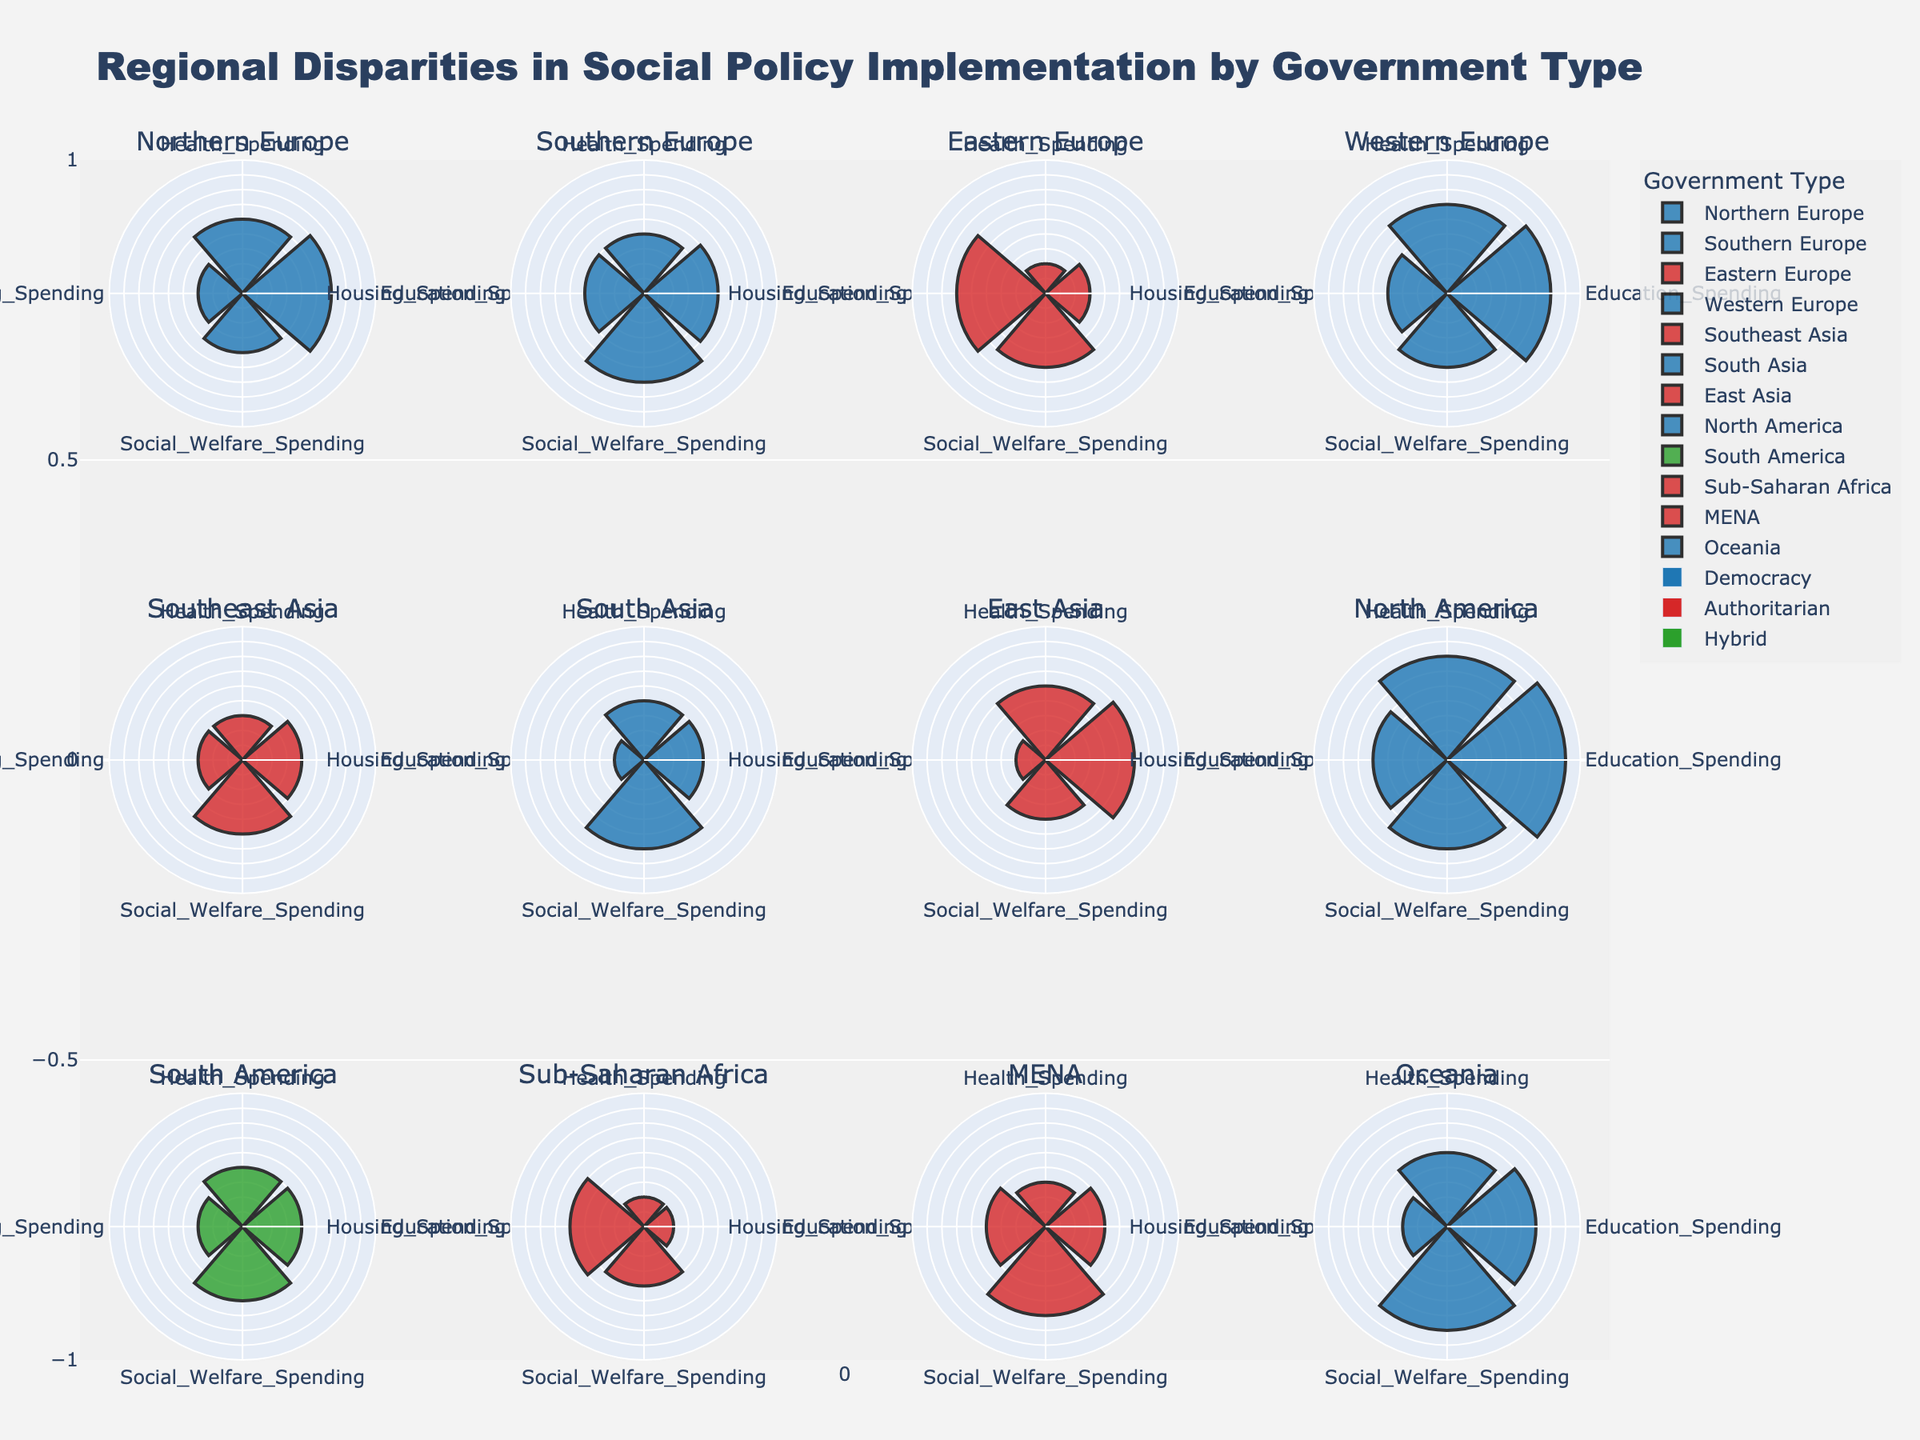Which region spends the most on health? The Northern Europe region, represented by a blue color indicating a democracy, shows the longest bar for health spending.
Answer: Northern Europe What is the government type of Southeast Asia, and how can you tell? The color of the bar polar for Southeast Asia is red, which is mapped to an authoritarian government type.
Answer: Authoritarian Which region under a democracy has the highest education spending? Looking at the rose charts for democratic regions, North America has the longest bar for education spending compared to other regions like Northern Europe, Western Europe, South Asia, and Oceania.
Answer: North America Compare the housing spending between East Asia and Southern Europe. In East Asia (authoritarian, red), the housing spending bar is shorter than in Southern Europe (democracy, blue), indicating lower housing expenditure in East Asia.
Answer: Southern Europe spends more on housing How does social welfare spending in South America compare to MENA? The green bar for South America’s social welfare spending is slightly shorter than the red bar for MENA’s social welfare spending, indicating MENA has marginally higher spending in this category.
Answer: MENA has higher social welfare spending For Authoritarian regions, identify the one with the highest health spending and provide the value. Among the red-colored sections, East Asia has the longest health spending bar, which is marked at 25 units.
Answer: East Asia with 25 units What is the social welfare spending for North America? In the North America subplot (democracy, blue), the bar for social welfare spending reaches up to 30 units.
Answer: 30 units Which region seems to have the most balanced spending across all four categories? Oceania (democracy, blue) shows relatively equal lengths for each category, indicating balanced spending.
Answer: Oceania Which region has the lowest health spending and what is the value? Sub-Saharan Africa (authoritarian, red) has the smallest value for health spending among all regions, marked at 10 units.
Answer: Sub-Saharan Africa with 10 units Is there any region where housing spending is the highest among all categories within the region? In the Eastern Europe subplot (authoritarian, red), the bar for housing spending is the highest compared to the other spending categories.
Answer: Eastern Europe 